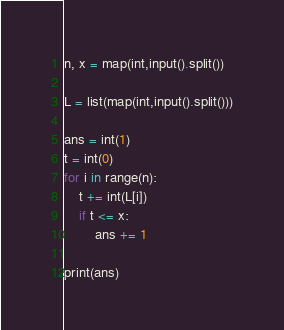Convert code to text. <code><loc_0><loc_0><loc_500><loc_500><_Python_>n, x = map(int,input().split())

L = list(map(int,input().split()))

ans = int(1)
t = int(0)
for i in range(n):
    t += int(L[i])
    if t <= x:
        ans += 1

print(ans)
</code> 